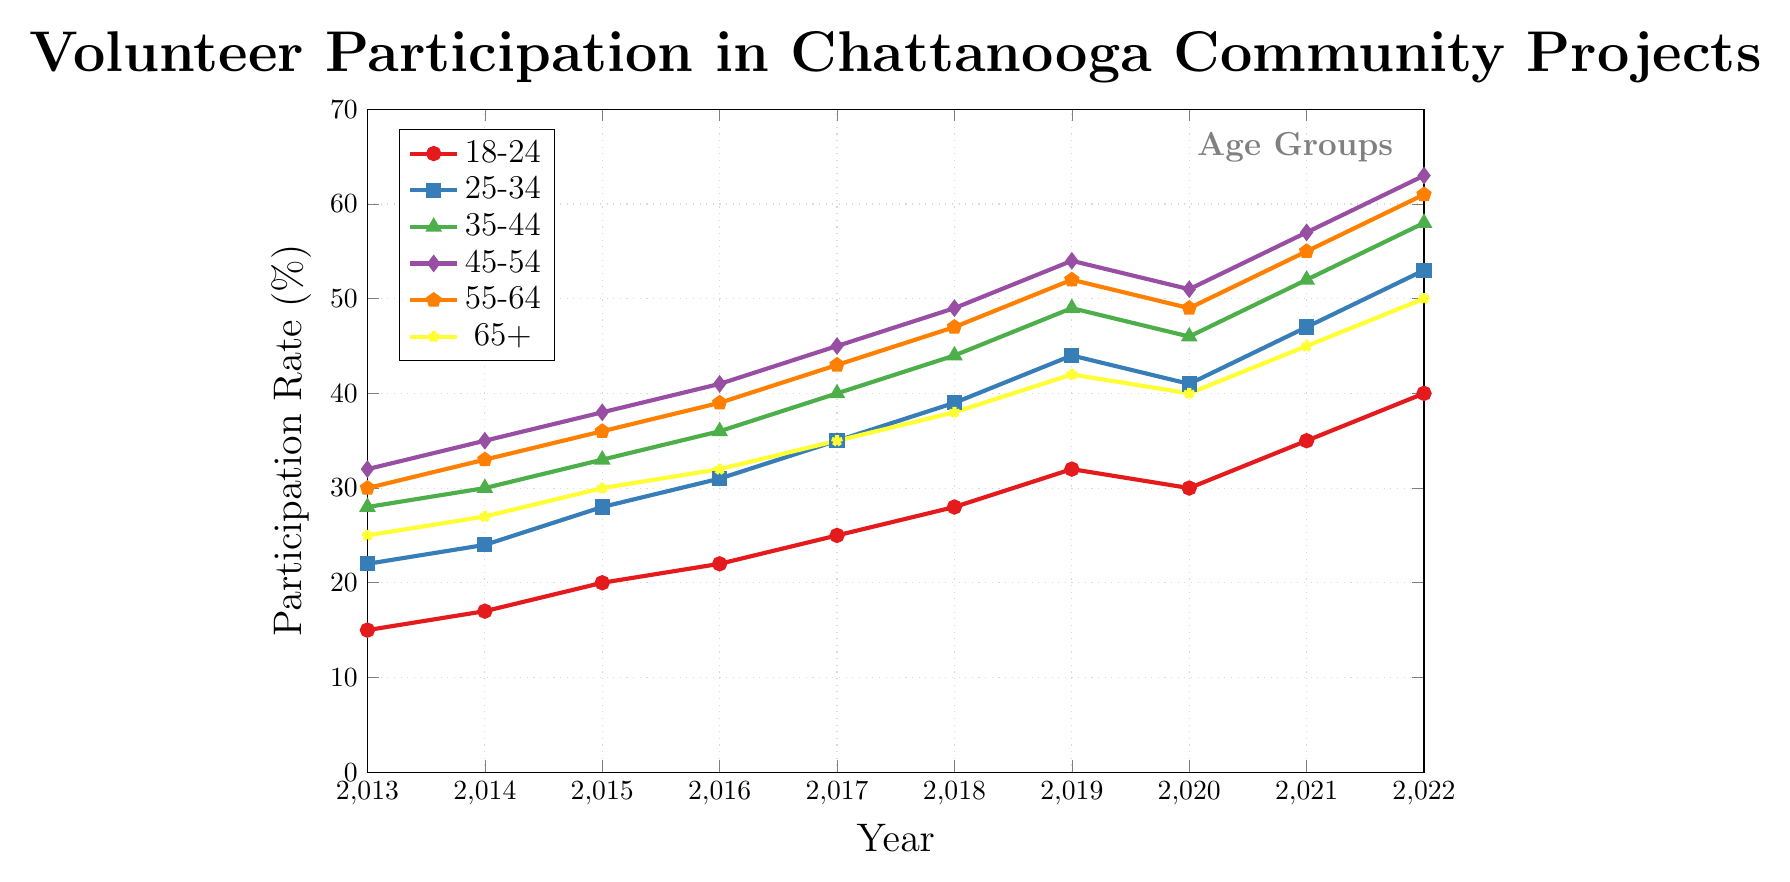What year did the 25-34 age group surpass the 35-44 age group in participation rates? By looking at the figure, we can see when the line representing the 25-34 age group (blue) surpasses the line for the 35-44 age group (green). The blue line crosses the green line around 2021.
Answer: 2021 What is the average participation rate for the 18-24 age group from 2013 to 2022? Sum the participation rates of the 18-24 age group across the years provided and divide by the number of years. The sum is (15 + 17 + 20 + 22 + 25 + 28 + 32 + 30 + 35 + 40) = 264. Divide by 10 to get the average: 264/10 = 26.4%.
Answer: 26.4% Which age group had the highest participation rate in 2022, and what was the rate? By looking at the figure for the year 2022, the highest line corresponds to the 45-54 age group (purple), with a rate of 63%.
Answer: 45-54, 63% What's the difference in the participation rates between the 45-54 and the 25-34 age groups in 2020? Observing the figure, the 45-54 age group had a rate of 51% in 2020, and the 25-34 age group had a rate of 41% in the same year. The difference is 51% - 41% = 10%.
Answer: 10% How did the participation rate of the 65+ age group change from 2019 to 2020? By observing the figure, the participation rate of the 65+ age group was 42% in 2019 and decreased to 40% in 2020. The change is 42% - 40% = -2%.
Answer: Decreased by 2% Did any age group show a decrease in participation rate in any year, and if so, which age group(s) and in which year(s)? From the figure, the 18-24 age group decreased from 2019 (32%) to 2020 (30%), and the 65+ age group decreased from 2019 (42%) to 2020 (40%). Both age groups show a decrease during this period.
Answer: 18-24 and 65+, in 2020 Which two age groups had the nearest participation rates in 2019? Looking at the figure for 2019, the participation rates are closest between the 55-64 (52%) and 45-54 (54%) age groups. The proximity is 54% - 52% = 2%, which is the smallest difference among all age groups in that year.
Answer: 55-64 and 45-54 What is the median participation rate for the 45-54 age group across the decade? List out the participation rates for the 45-54 age group from 2013 to 2022: (32, 35, 38, 41, 45, 49, 54, 51, 57, 63). Ordering them: (32, 35, 38, 41, 45, 49, 51, 54, 57, 63). The median is the average of the 5th and 6th numbers: (45 + 49) / 2 = 47%.
Answer: 47% In which year did the 35-44 age group reach a participation rate of 50% or more? Reviewing the plot, the 35-44 age group reached a participation rate of 50% or more in 2022.
Answer: 2022 Which age group showed the most consistent increase in participation rates from 2013 to 2022? We need to observe the slope of the lines for each age group across the years. The 25-34 age group (blue) shows a steady and consistent increase from 22% in 2013 to 53% in 2022 without any decrease.
Answer: 25-34 